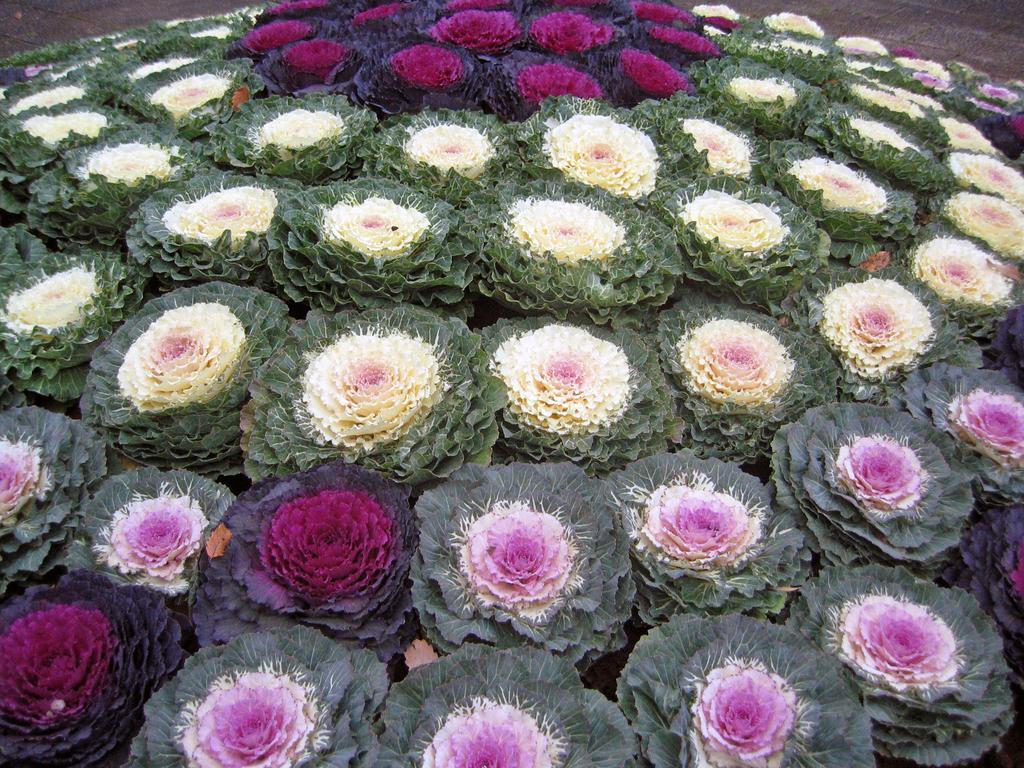Describe this image in one or two sentences. In this picture I can see different colors of flowers. 